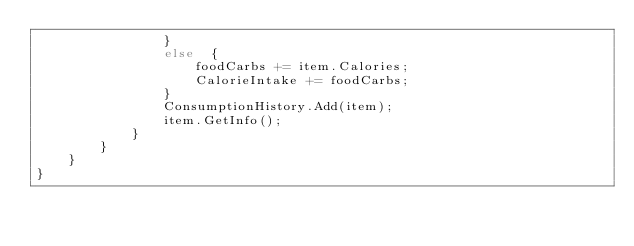<code> <loc_0><loc_0><loc_500><loc_500><_C#_>                }
                else  {
                    foodCarbs += item.Calories;
                    CalorieIntake += foodCarbs;
                }
                ConsumptionHistory.Add(item);
                item.GetInfo();
            }
        }
    }
}</code> 